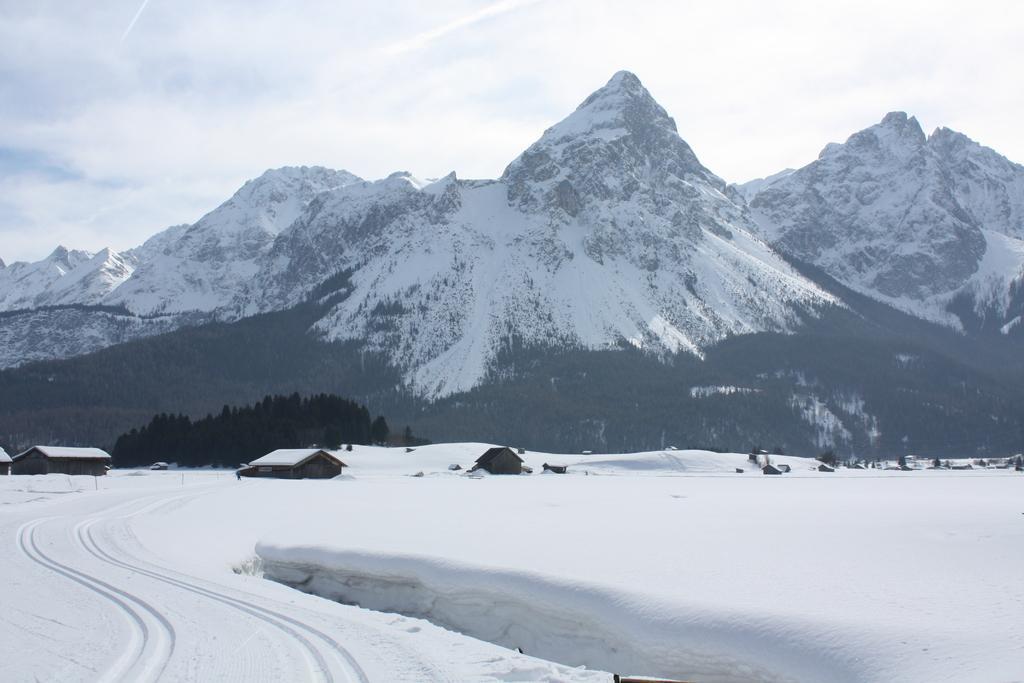How would you summarize this image in a sentence or two? In the foreground of this image, there is snow. In the middle, there are houses and trees. At the top, there are mountains, sky and the cloud. 